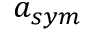Convert formula to latex. <formula><loc_0><loc_0><loc_500><loc_500>a _ { s y m }</formula> 